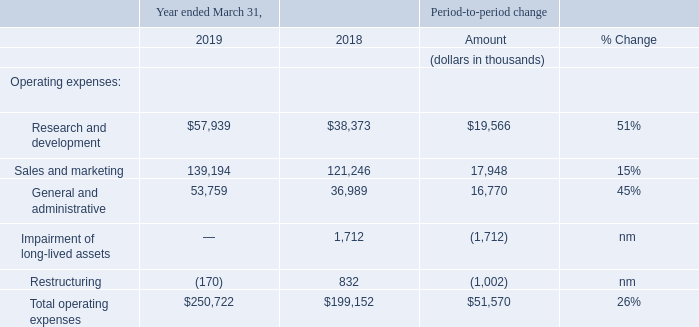Operating expenses
nm—not meaningful
Research and development expenses
Research and development expenses increased $19.6 million in the year ended March 31, 2019 compared to the year ended March 31, 2018, which was primarily attributable to increases in personnel-related costs of $11.8 million, share-based compensation expense of $3.6 million and information technology and facility costs of $1.6 million.
Research and development expenses for the year ended March 31, 2019 as compared to the year ended March 31, 2018 were positively impacted by approximately $0.5 million primarily as a result of the strengthening of the U.S. dollar relative to the British pound.
Personnel-related cost increased primarily as a result of salaries and benefits associated with increased headcount throughout the year, share-based compensation expense increased primarily as a result of share option grants since the prior year and information technology and facility costs increased primarily as a result of increased headcount.
Sales and marketing expenses
Sales and marketing expenses increased $17.9 million in the year ended March 31, 2019 compared to the year ended March 31, 2018, which was primarily attributable to increases in information technology and facilities costs of $5.3 million, personnel-related costs of $4.0 million, share-based compensation expense of $3.4 million, professional services of $2.7 million, travel and other costs of $1.2 million and marketing costs of $1.1 million.
Sales and marketing expenses for the year ended March 31, 2019 as compared to the year ended March 31, 2018 were positively impacted by approximately $1.5 million primarily as a result of the strengthening of the U.S. dollar relative to the Australian dollar, South African rand and British pound. Information technology and facilities costs and travel and other costs increased primarily as a result of increased headcount.
Personnel-related costs increased primarily as a result of salaries and benefits associated with increased headcount and commissions, partially offset by the impact of adopting ASC 606, which resulted in capitalizing $13.8 million of commissions that would have been expensed under the prior accounting rules. Share-based compensation expense increased primarily as a result of share option grants since the prior year. Professional services costs increased primarily due to increased consulting fees.
General and administrative expenses
General and administrative expenses increased $16.8 million in the year ended March 31, 2019 compared to the year ended March 31, 2018, which was primarily attributable to increases in personnel-related costs of $6.3 million, share-based compensation expense of $5.8 million, information technology and facilities costs of $1.9 million, professional services costs of $1.2 million and litigation-related expenses of $1.0 million. Personnel-related costs increased primarily as a result of salaries and benefits associated with increased headcount.
Share-based compensation expense increased primarily as a result of share option grants since the prior year and to a lesser extent the impact of share option modifications. Information technology and facility costs increased primarily as a result of increased headcount. Professional services costs increased primarily due to acquisition-related expenses.
Restructuring and Impairment of long-lived assets
In the second quarter of fiscal 2019, we recorded a revision to restructuring expense of $0.2 million related to the exit of our Watertown, Massachusetts corporate office space. In the fourth quarter of fiscal 2018, upon the exit of our Watertown, Massachusetts corporate office space, we recorded a restructuring charge of $0.8 million for the remaining non-cancelable rent and estimated operating expenses for the vacated premises, net of sublease rentals and we recorded a non-cash impairment charge of $1.7 million primarily related to leasehold improvements.
What was the increase in the General and administrative expenses in 2019? $16.8 million. What caused the share-based compensation expense to increase? Primarily as a result of share option grants since the prior year and to a lesser extent the impact of share option modifications. What was the Research and development expense in 2019 and 2018 respectively?
Answer scale should be: thousand. $57,939, $38,373. What was the average Sales and marketing expense for 2018 and 2019?
Answer scale should be: thousand. 139,194 - 121,246
Answer: 17948. What percentage of total operating expenses was General and administrative in 2019?
Answer scale should be: percent. 53,759 / 250,722
Answer: 21.44. In which year was Total operating expenses less than 200,000 thousands? Locate and analyze total operating expenses in row 10
answer: 2018. 